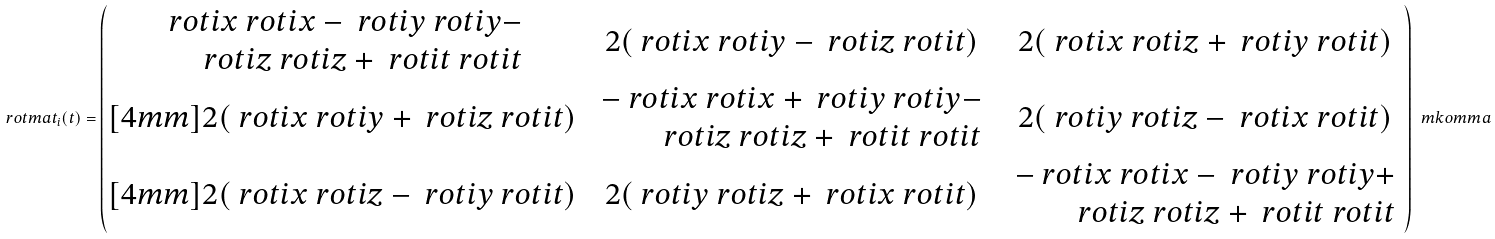Convert formula to latex. <formula><loc_0><loc_0><loc_500><loc_500>\ r o t m a t _ { i } ( t ) = \begin{pmatrix} \begin{array} { r } \ r o t i x \ r o t i x - \ r o t i y \ r o t i y - \\ \ r o t i z \ r o t i z + \ r o t i t \ r o t i t \end{array} & 2 ( \ r o t i x \ r o t i y - \ r o t i z \ r o t i t ) & 2 ( \ r o t i x \ r o t i z + \ r o t i y \ r o t i t ) \\ [ 4 m m ] 2 ( \ r o t i x \ r o t i y + \ r o t i z \ r o t i t ) & \begin{array} { r } - \ r o t i x \ r o t i x + \ r o t i y \ r o t i y - \\ \ r o t i z \ r o t i z + \ r o t i t \ r o t i t \end{array} & 2 ( \ r o t i y \ r o t i z - \ r o t i x \ r o t i t ) \\ [ 4 m m ] 2 ( \ r o t i x \ r o t i z - \ r o t i y \ r o t i t ) & 2 ( \ r o t i y \ r o t i z + \ r o t i x \ r o t i t ) & \begin{array} { r } - \ r o t i x \ r o t i x - \ r o t i y \ r o t i y + \\ \ r o t i z \ r o t i z + \ r o t i t \ r o t i t \end{array} \end{pmatrix} \ m k o m m a</formula> 